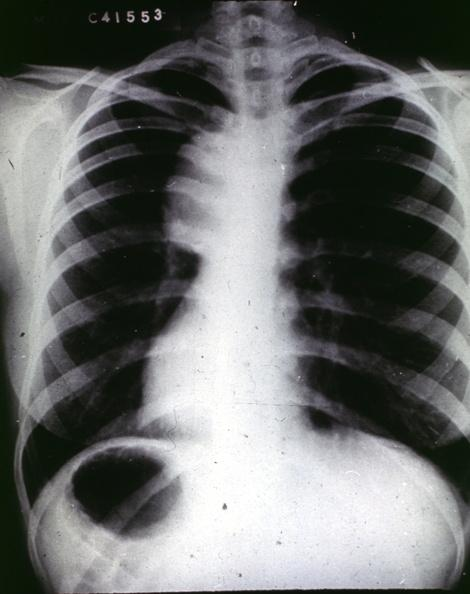what does this image show?
Answer the question using a single word or phrase. Traumatic aneurysm aortogram 